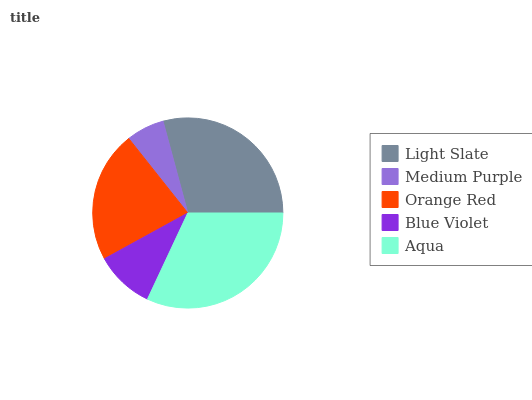Is Medium Purple the minimum?
Answer yes or no. Yes. Is Aqua the maximum?
Answer yes or no. Yes. Is Orange Red the minimum?
Answer yes or no. No. Is Orange Red the maximum?
Answer yes or no. No. Is Orange Red greater than Medium Purple?
Answer yes or no. Yes. Is Medium Purple less than Orange Red?
Answer yes or no. Yes. Is Medium Purple greater than Orange Red?
Answer yes or no. No. Is Orange Red less than Medium Purple?
Answer yes or no. No. Is Orange Red the high median?
Answer yes or no. Yes. Is Orange Red the low median?
Answer yes or no. Yes. Is Medium Purple the high median?
Answer yes or no. No. Is Light Slate the low median?
Answer yes or no. No. 